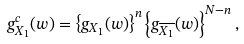<formula> <loc_0><loc_0><loc_500><loc_500>g ^ { c } _ { X _ { 1 } } ( w ) = \left \{ g _ { X _ { 1 } } ( w ) \right \} ^ { n } \left \{ g _ { \overline { X _ { 1 } } } ( w ) \right \} ^ { N - n } ,</formula> 